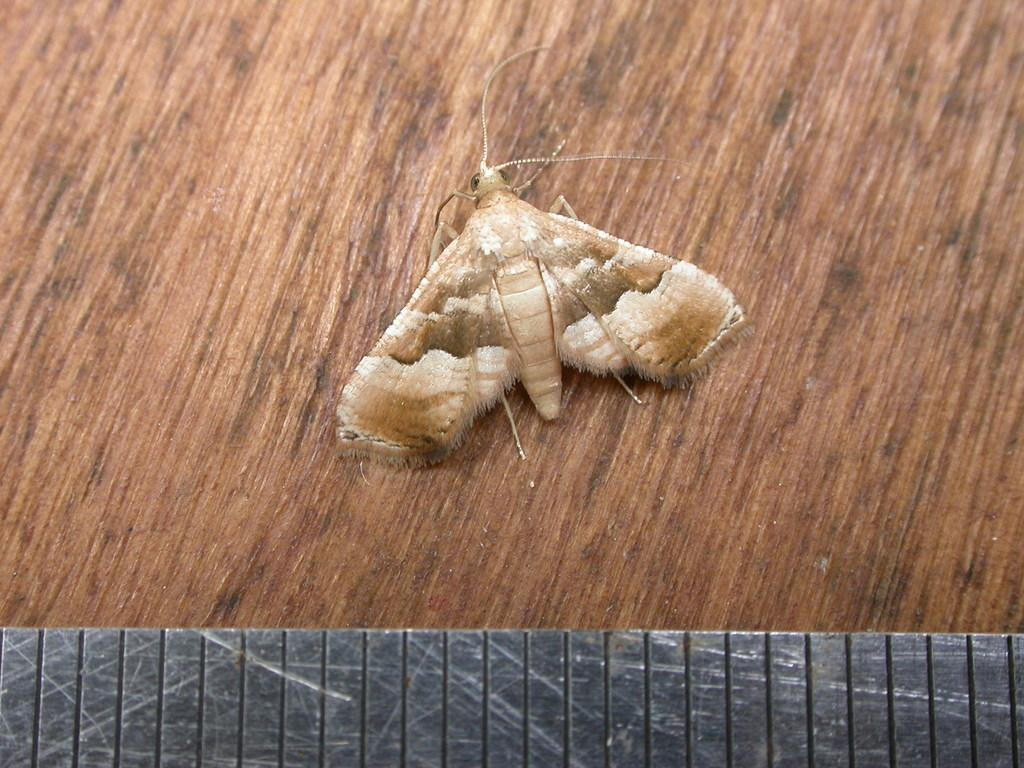What type of creature is present in the image? There is an insect in the image. What is the insect resting on? The insect is on a wooden object. What can be seen behind the insect? There is an iron plate visible behind the insect. What type of veil is covering the insect in the image? There is no veil present in the image; the insect is not covered. 